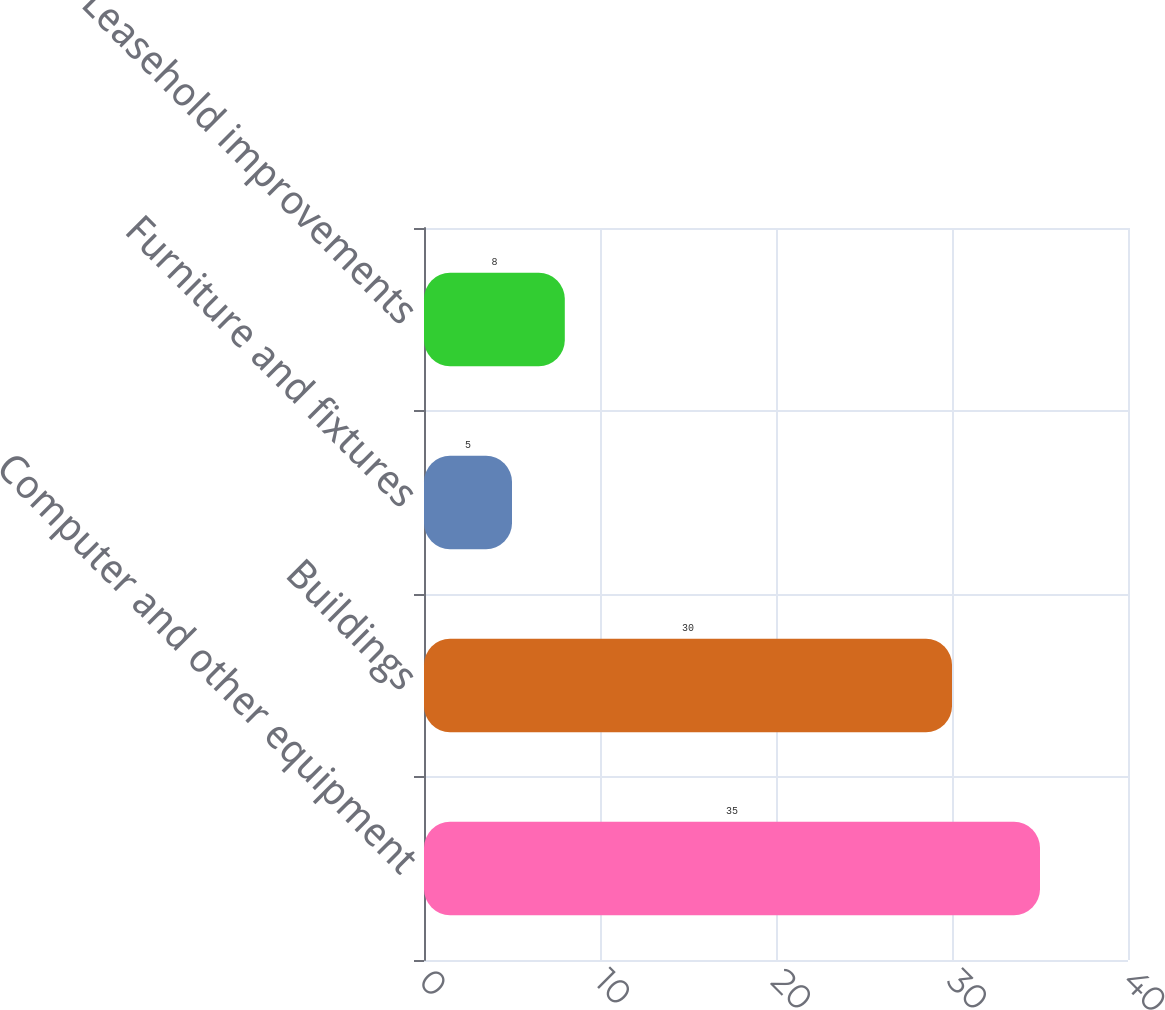Convert chart to OTSL. <chart><loc_0><loc_0><loc_500><loc_500><bar_chart><fcel>Computer and other equipment<fcel>Buildings<fcel>Furniture and fixtures<fcel>Leasehold improvements<nl><fcel>35<fcel>30<fcel>5<fcel>8<nl></chart> 